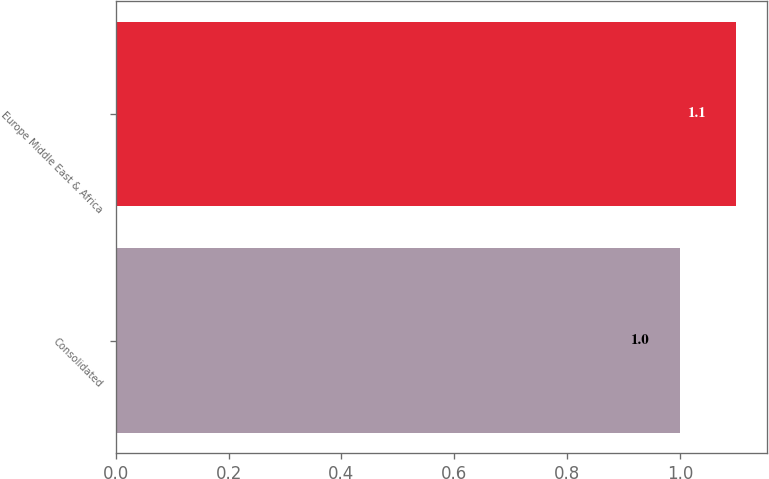Convert chart. <chart><loc_0><loc_0><loc_500><loc_500><bar_chart><fcel>Consolidated<fcel>Europe Middle East & Africa<nl><fcel>1<fcel>1.1<nl></chart> 